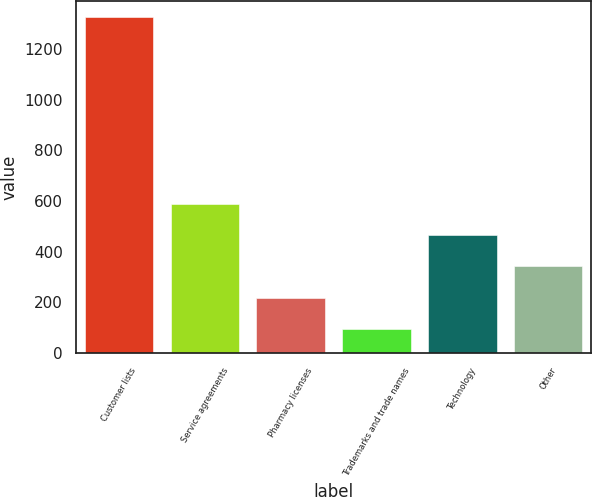Convert chart. <chart><loc_0><loc_0><loc_500><loc_500><bar_chart><fcel>Customer lists<fcel>Service agreements<fcel>Pharmacy licenses<fcel>Trademarks and trade names<fcel>Technology<fcel>Other<nl><fcel>1324<fcel>587.2<fcel>218.8<fcel>96<fcel>464.4<fcel>341.6<nl></chart> 